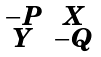Convert formula to latex. <formula><loc_0><loc_0><loc_500><loc_500>\begin{smallmatrix} - P & X \\ Y & - Q \end{smallmatrix}</formula> 